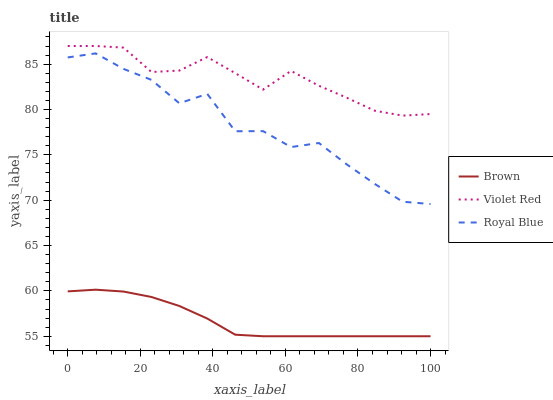Does Brown have the minimum area under the curve?
Answer yes or no. Yes. Does Violet Red have the maximum area under the curve?
Answer yes or no. Yes. Does Royal Blue have the minimum area under the curve?
Answer yes or no. No. Does Royal Blue have the maximum area under the curve?
Answer yes or no. No. Is Brown the smoothest?
Answer yes or no. Yes. Is Royal Blue the roughest?
Answer yes or no. Yes. Is Violet Red the smoothest?
Answer yes or no. No. Is Violet Red the roughest?
Answer yes or no. No. Does Brown have the lowest value?
Answer yes or no. Yes. Does Royal Blue have the lowest value?
Answer yes or no. No. Does Violet Red have the highest value?
Answer yes or no. Yes. Does Royal Blue have the highest value?
Answer yes or no. No. Is Royal Blue less than Violet Red?
Answer yes or no. Yes. Is Royal Blue greater than Brown?
Answer yes or no. Yes. Does Royal Blue intersect Violet Red?
Answer yes or no. No. 